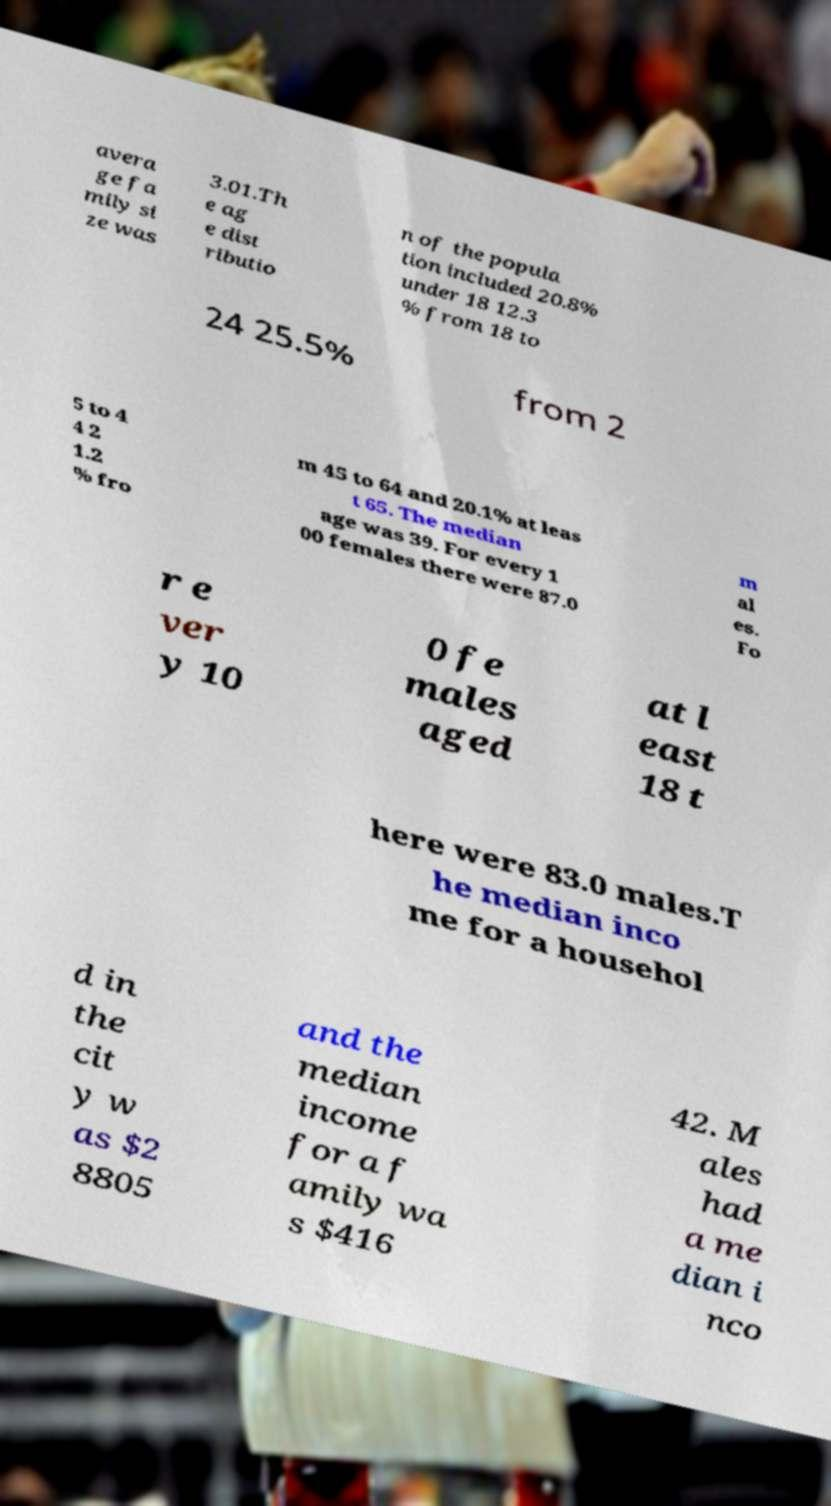Please identify and transcribe the text found in this image. avera ge fa mily si ze was 3.01.Th e ag e dist ributio n of the popula tion included 20.8% under 18 12.3 % from 18 to 24 25.5% from 2 5 to 4 4 2 1.2 % fro m 45 to 64 and 20.1% at leas t 65. The median age was 39. For every 1 00 females there were 87.0 m al es. Fo r e ver y 10 0 fe males aged at l east 18 t here were 83.0 males.T he median inco me for a househol d in the cit y w as $2 8805 and the median income for a f amily wa s $416 42. M ales had a me dian i nco 